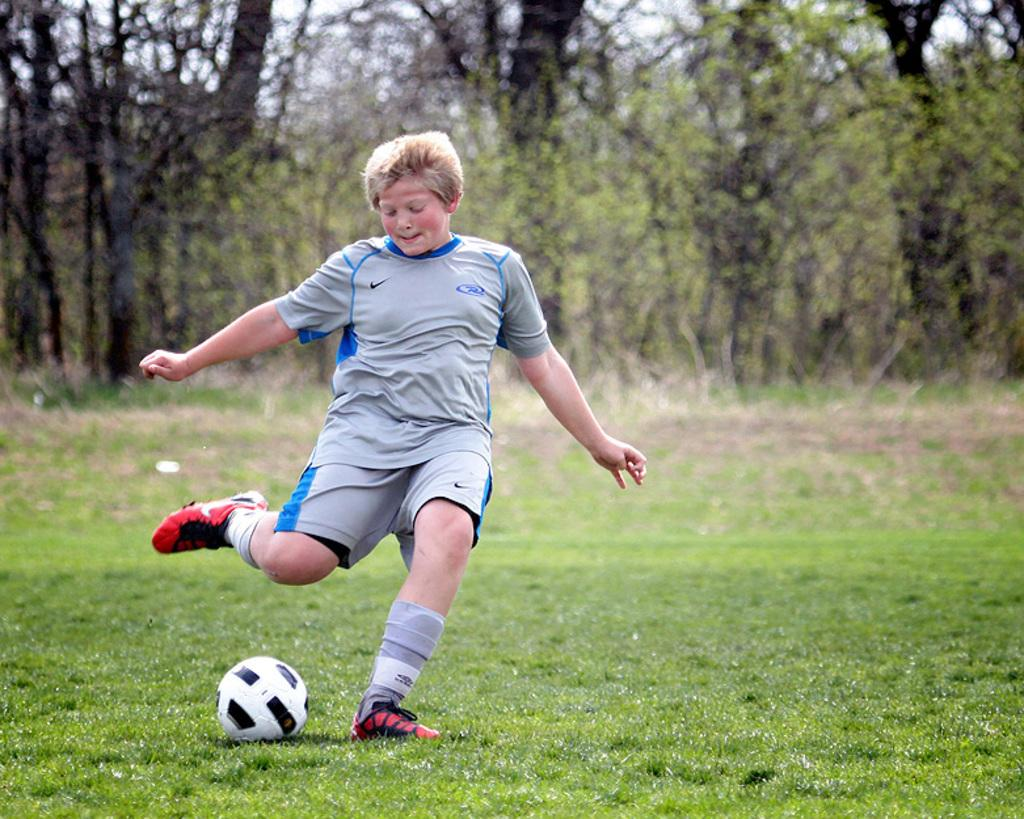What is the main subject of the image? There is a person in the image. What is the person wearing? The person is wearing a grey dress. What activity is the person engaged in? The person is playing football. What is the color of the ground in the image? The ground is green. What can be seen in the background of the image? There are trees in the background of the image. What type of crayon is the person using to draw on the football in the image? There is no crayon or drawing on the football in the image; the person is playing football. 